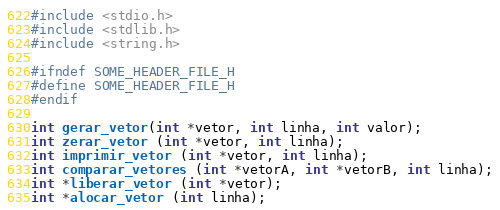Convert code to text. <code><loc_0><loc_0><loc_500><loc_500><_C_>#include <stdio.h>
#include <stdlib.h>
#include <string.h>

#ifndef SOME_HEADER_FILE_H
#define SOME_HEADER_FILE_H
#endif

int gerar_vetor(int *vetor, int linha, int valor);
int zerar_vetor (int *vetor, int linha);
int imprimir_vetor (int *vetor, int linha);
int comparar_vetores (int *vetorA, int *vetorB, int linha);
int *liberar_vetor (int *vetor);
int *alocar_vetor (int linha);
</code> 